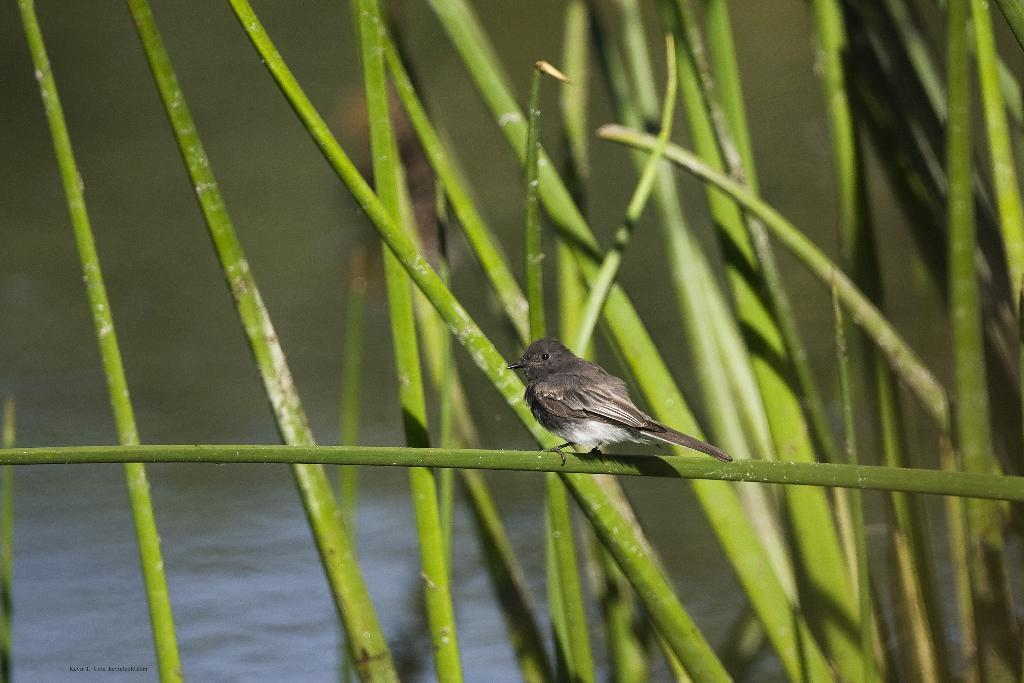What type of vegetation is present in the image? There is grass in the image. What animal can be seen on the grass? There is a bird on the grass. What can be seen in the distance in the image? There is water visible in the background of the image. What type of pleasure can be seen being experienced by the division in the image? There is no pleasure, division, or any related concepts present in the image. The image features grass, a bird, and water in the background. 